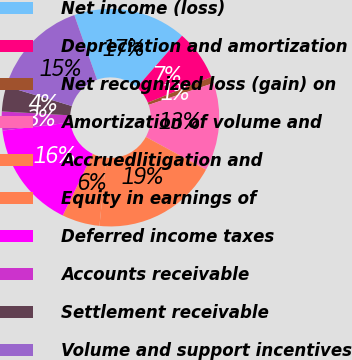Convert chart. <chart><loc_0><loc_0><loc_500><loc_500><pie_chart><fcel>Net income (loss)<fcel>Depreciation and amortization<fcel>Net recognized loss (gain) on<fcel>Amortization of volume and<fcel>Accruedlitigation and<fcel>Equity in earnings of<fcel>Deferred income taxes<fcel>Accounts receivable<fcel>Settlement receivable<fcel>Volume and support incentives<nl><fcel>16.82%<fcel>7.48%<fcel>0.94%<fcel>13.08%<fcel>18.68%<fcel>5.61%<fcel>15.88%<fcel>2.81%<fcel>3.74%<fcel>14.95%<nl></chart> 